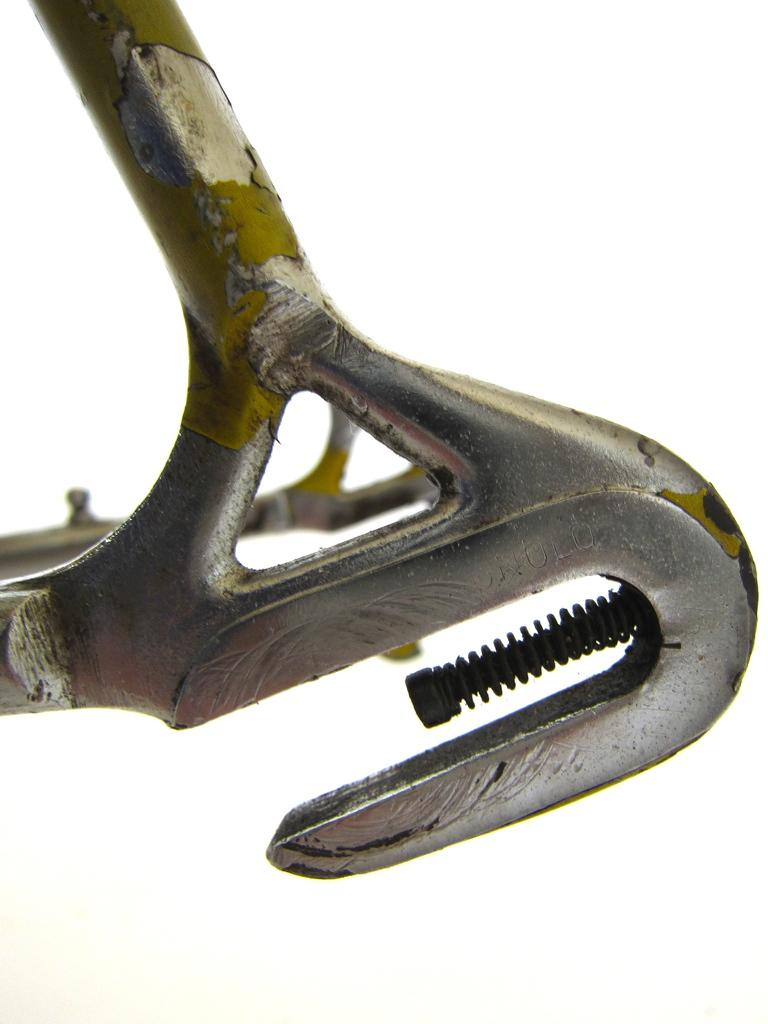What type of object can be seen in the image? There is an iron object in the image. How many kisses are exchanged between the two people in the image? There are no people present in the image, and therefore no kisses can be observed. What time of day is depicted in the image? The provided facts do not mention the time of day, and there is no indication of time in the image. 